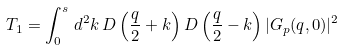Convert formula to latex. <formula><loc_0><loc_0><loc_500><loc_500>T _ { 1 } = \int _ { 0 } ^ { s } \, d ^ { 2 } k \, D \left ( \frac { q } { 2 } + k \right ) D \left ( \frac { q } { 2 } - k \right ) | G _ { p } ( q , 0 ) | ^ { 2 }</formula> 